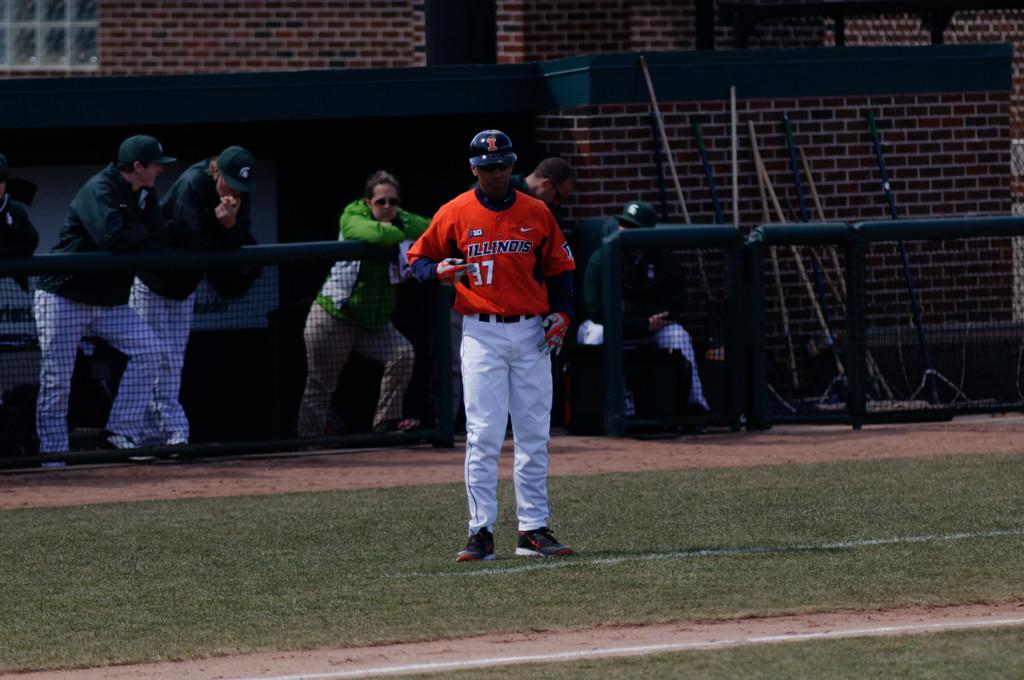<image>
Give a short and clear explanation of the subsequent image. A baseball player in a red top bearing the number 37 stands on the field whilst behind him, several spectators look on. 